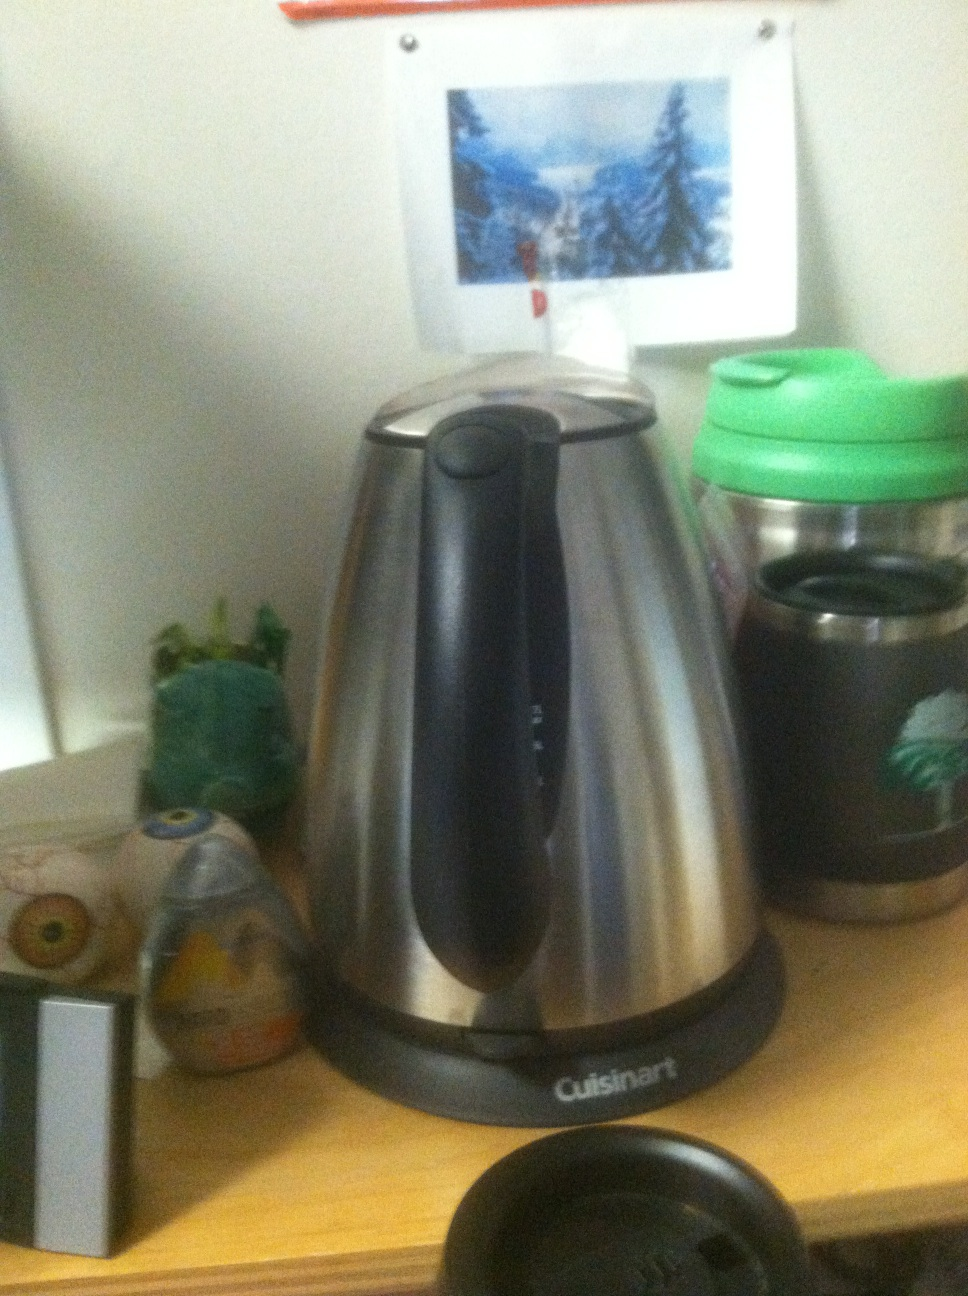What is this? What is this? from Vizwiz cuisinart coffee pot 